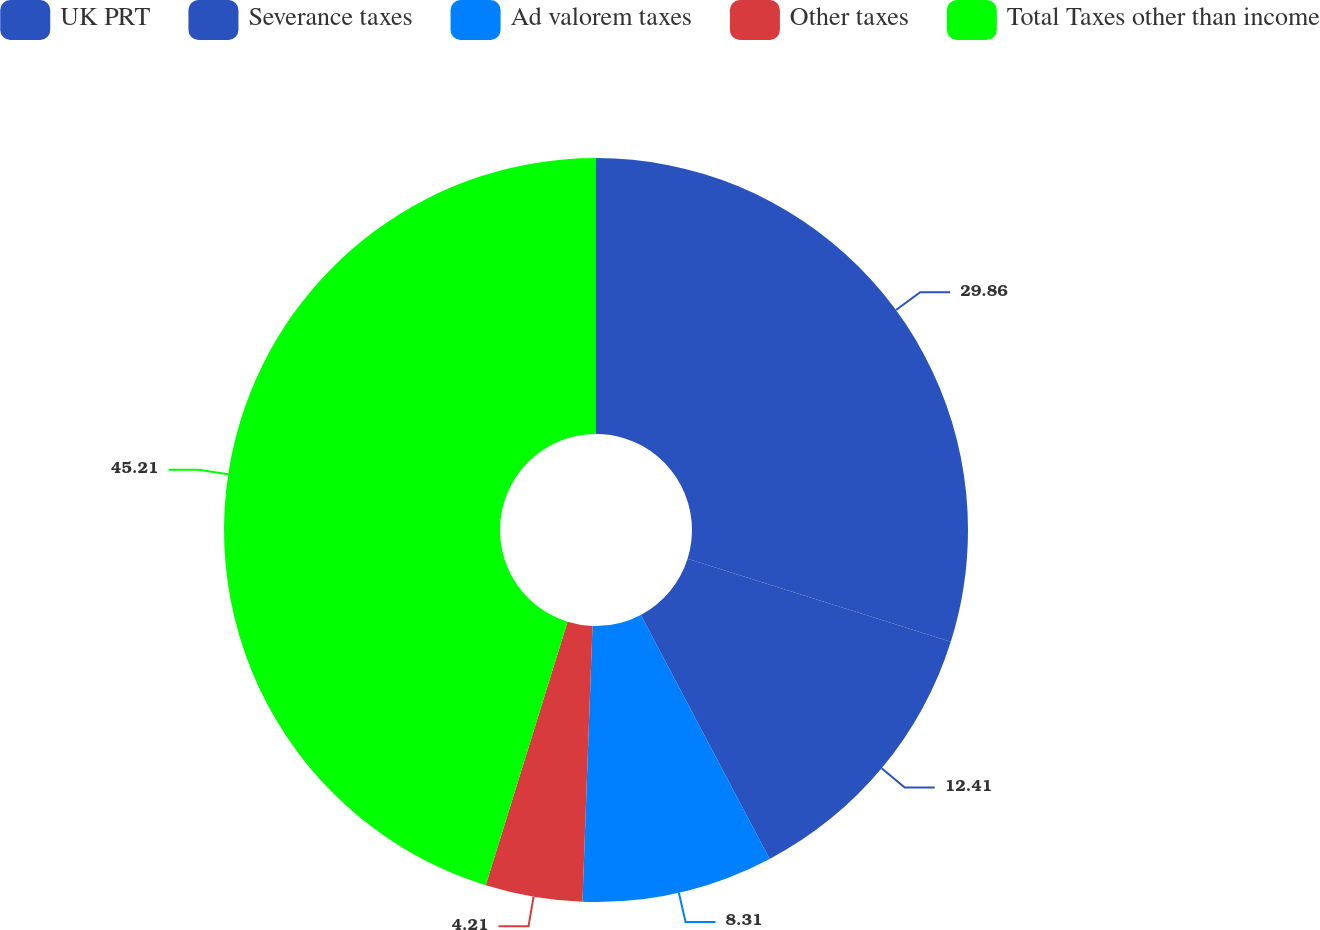<chart> <loc_0><loc_0><loc_500><loc_500><pie_chart><fcel>UK PRT<fcel>Severance taxes<fcel>Ad valorem taxes<fcel>Other taxes<fcel>Total Taxes other than income<nl><fcel>29.86%<fcel>12.41%<fcel>8.31%<fcel>4.21%<fcel>45.21%<nl></chart> 